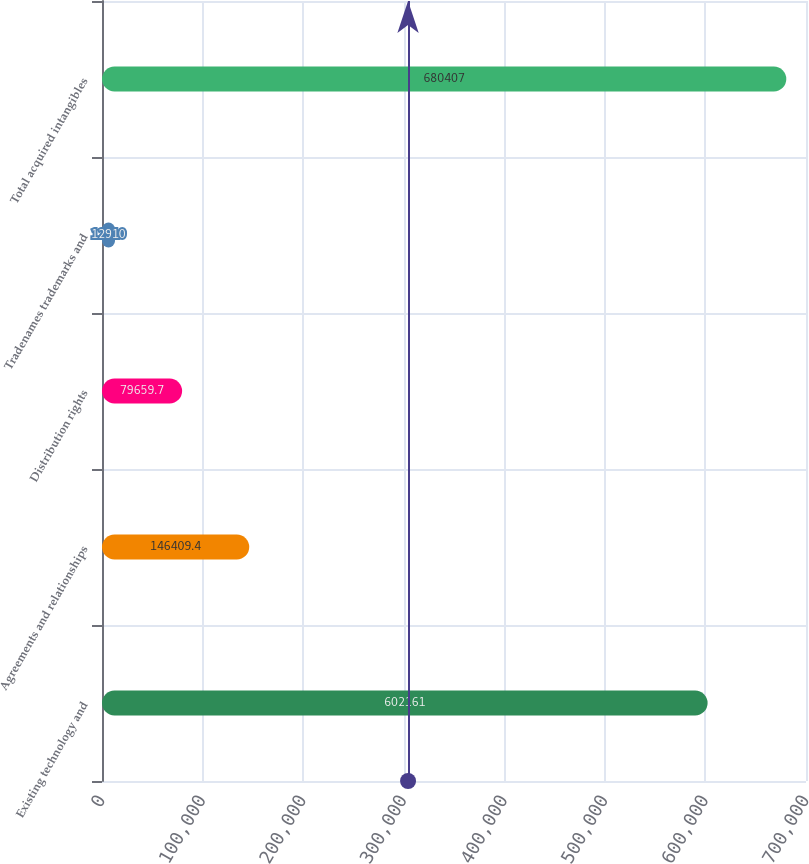Convert chart to OTSL. <chart><loc_0><loc_0><loc_500><loc_500><bar_chart><fcel>Existing technology and<fcel>Agreements and relationships<fcel>Distribution rights<fcel>Tradenames trademarks and<fcel>Total acquired intangibles<nl><fcel>602161<fcel>146409<fcel>79659.7<fcel>12910<fcel>680407<nl></chart> 